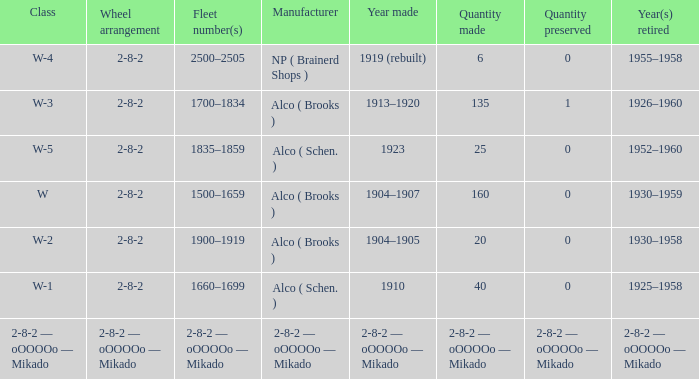What is the year retired of the locomotive which had the quantity made of 25? 1952–1960. 